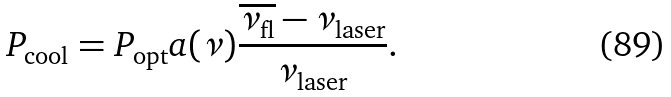<formula> <loc_0><loc_0><loc_500><loc_500>P _ { \text {cool} } = P _ { \text {opt} } a ( { \nu } ) \frac { \overline { \nu _ { \text {fl} } } - \nu _ { \text {laser} } } { \nu _ { \text {laser} } } .</formula> 